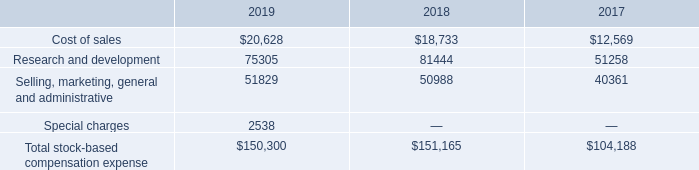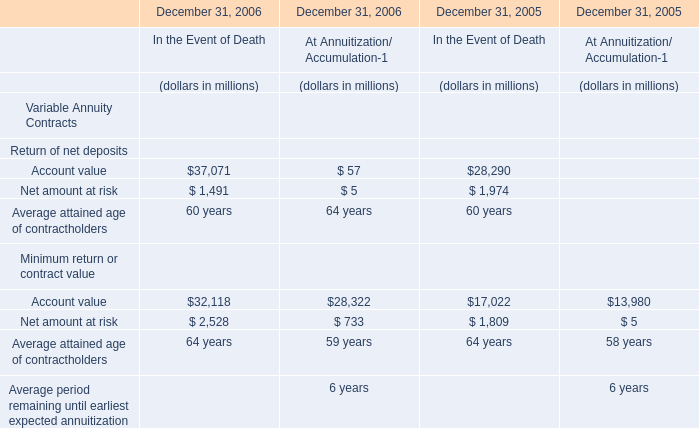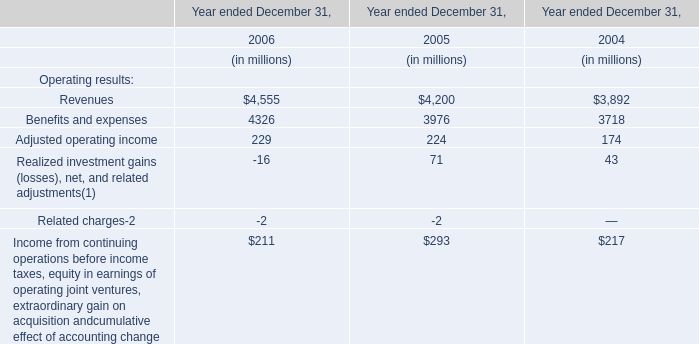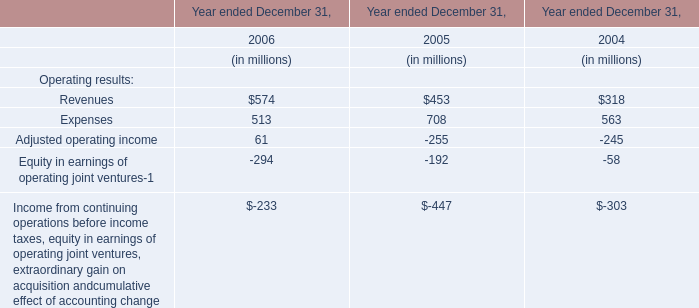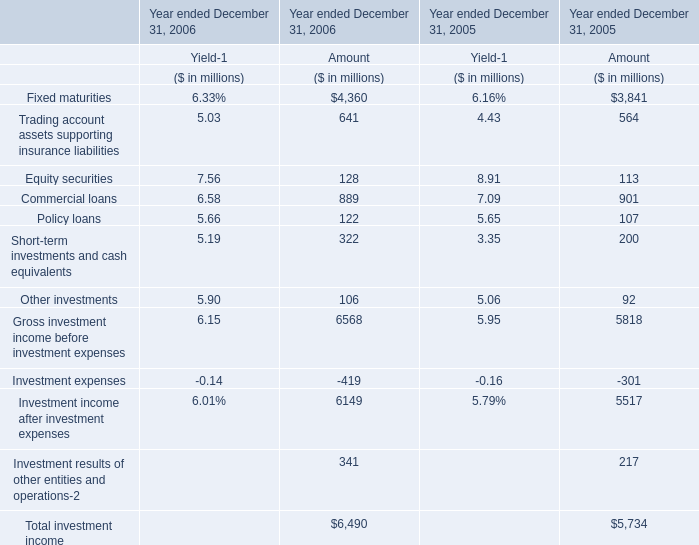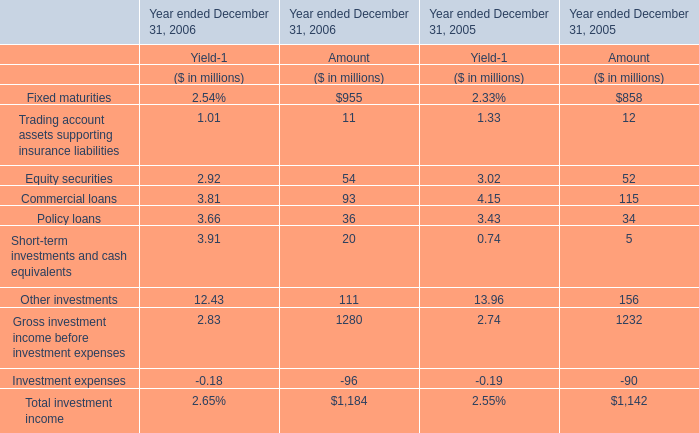What's the growth rate of Fixed maturities in 2006 for Amount? 
Computations: ((955 - 858) / 955)
Answer: 0.10157. 